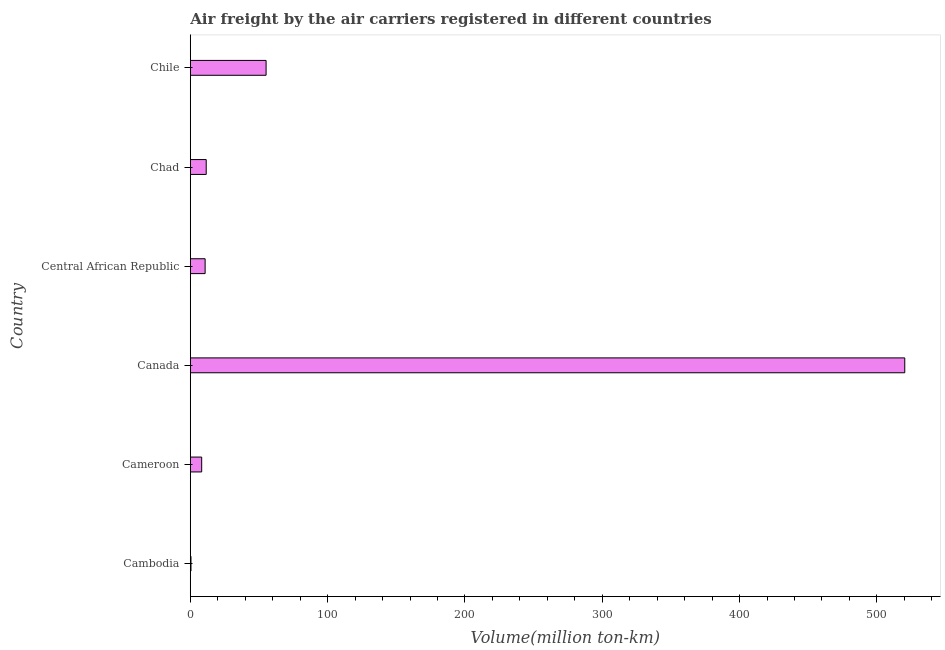Does the graph contain any zero values?
Your answer should be compact. No. Does the graph contain grids?
Offer a terse response. No. What is the title of the graph?
Make the answer very short. Air freight by the air carriers registered in different countries. What is the label or title of the X-axis?
Keep it short and to the point. Volume(million ton-km). What is the label or title of the Y-axis?
Provide a short and direct response. Country. What is the air freight in Canada?
Provide a succinct answer. 520.3. Across all countries, what is the maximum air freight?
Your response must be concise. 520.3. In which country was the air freight maximum?
Ensure brevity in your answer.  Canada. In which country was the air freight minimum?
Keep it short and to the point. Cambodia. What is the sum of the air freight?
Your answer should be very brief. 606.7. What is the difference between the air freight in Canada and Central African Republic?
Keep it short and to the point. 509.5. What is the average air freight per country?
Give a very brief answer. 101.12. What is the median air freight?
Your response must be concise. 11.2. In how many countries, is the air freight greater than 360 million ton-km?
Ensure brevity in your answer.  1. What is the ratio of the air freight in Chad to that in Chile?
Make the answer very short. 0.21. What is the difference between the highest and the second highest air freight?
Offer a terse response. 465.1. Is the sum of the air freight in Cambodia and Canada greater than the maximum air freight across all countries?
Your answer should be very brief. Yes. What is the difference between the highest and the lowest air freight?
Your response must be concise. 519.8. In how many countries, is the air freight greater than the average air freight taken over all countries?
Provide a succinct answer. 1. What is the Volume(million ton-km) of Cameroon?
Give a very brief answer. 8.3. What is the Volume(million ton-km) of Canada?
Offer a terse response. 520.3. What is the Volume(million ton-km) of Central African Republic?
Provide a short and direct response. 10.8. What is the Volume(million ton-km) in Chad?
Your answer should be very brief. 11.6. What is the Volume(million ton-km) in Chile?
Ensure brevity in your answer.  55.2. What is the difference between the Volume(million ton-km) in Cambodia and Cameroon?
Your answer should be very brief. -7.8. What is the difference between the Volume(million ton-km) in Cambodia and Canada?
Offer a very short reply. -519.8. What is the difference between the Volume(million ton-km) in Cambodia and Chile?
Make the answer very short. -54.7. What is the difference between the Volume(million ton-km) in Cameroon and Canada?
Provide a succinct answer. -512. What is the difference between the Volume(million ton-km) in Cameroon and Central African Republic?
Provide a succinct answer. -2.5. What is the difference between the Volume(million ton-km) in Cameroon and Chile?
Your answer should be very brief. -46.9. What is the difference between the Volume(million ton-km) in Canada and Central African Republic?
Provide a short and direct response. 509.5. What is the difference between the Volume(million ton-km) in Canada and Chad?
Offer a terse response. 508.7. What is the difference between the Volume(million ton-km) in Canada and Chile?
Give a very brief answer. 465.1. What is the difference between the Volume(million ton-km) in Central African Republic and Chad?
Your answer should be compact. -0.8. What is the difference between the Volume(million ton-km) in Central African Republic and Chile?
Offer a very short reply. -44.4. What is the difference between the Volume(million ton-km) in Chad and Chile?
Offer a very short reply. -43.6. What is the ratio of the Volume(million ton-km) in Cambodia to that in Cameroon?
Make the answer very short. 0.06. What is the ratio of the Volume(million ton-km) in Cambodia to that in Canada?
Ensure brevity in your answer.  0. What is the ratio of the Volume(million ton-km) in Cambodia to that in Central African Republic?
Ensure brevity in your answer.  0.05. What is the ratio of the Volume(million ton-km) in Cambodia to that in Chad?
Your answer should be compact. 0.04. What is the ratio of the Volume(million ton-km) in Cambodia to that in Chile?
Your answer should be very brief. 0.01. What is the ratio of the Volume(million ton-km) in Cameroon to that in Canada?
Keep it short and to the point. 0.02. What is the ratio of the Volume(million ton-km) in Cameroon to that in Central African Republic?
Provide a succinct answer. 0.77. What is the ratio of the Volume(million ton-km) in Cameroon to that in Chad?
Ensure brevity in your answer.  0.72. What is the ratio of the Volume(million ton-km) in Cameroon to that in Chile?
Your answer should be compact. 0.15. What is the ratio of the Volume(million ton-km) in Canada to that in Central African Republic?
Provide a short and direct response. 48.18. What is the ratio of the Volume(million ton-km) in Canada to that in Chad?
Your response must be concise. 44.85. What is the ratio of the Volume(million ton-km) in Canada to that in Chile?
Your response must be concise. 9.43. What is the ratio of the Volume(million ton-km) in Central African Republic to that in Chad?
Offer a very short reply. 0.93. What is the ratio of the Volume(million ton-km) in Central African Republic to that in Chile?
Offer a very short reply. 0.2. What is the ratio of the Volume(million ton-km) in Chad to that in Chile?
Your answer should be very brief. 0.21. 